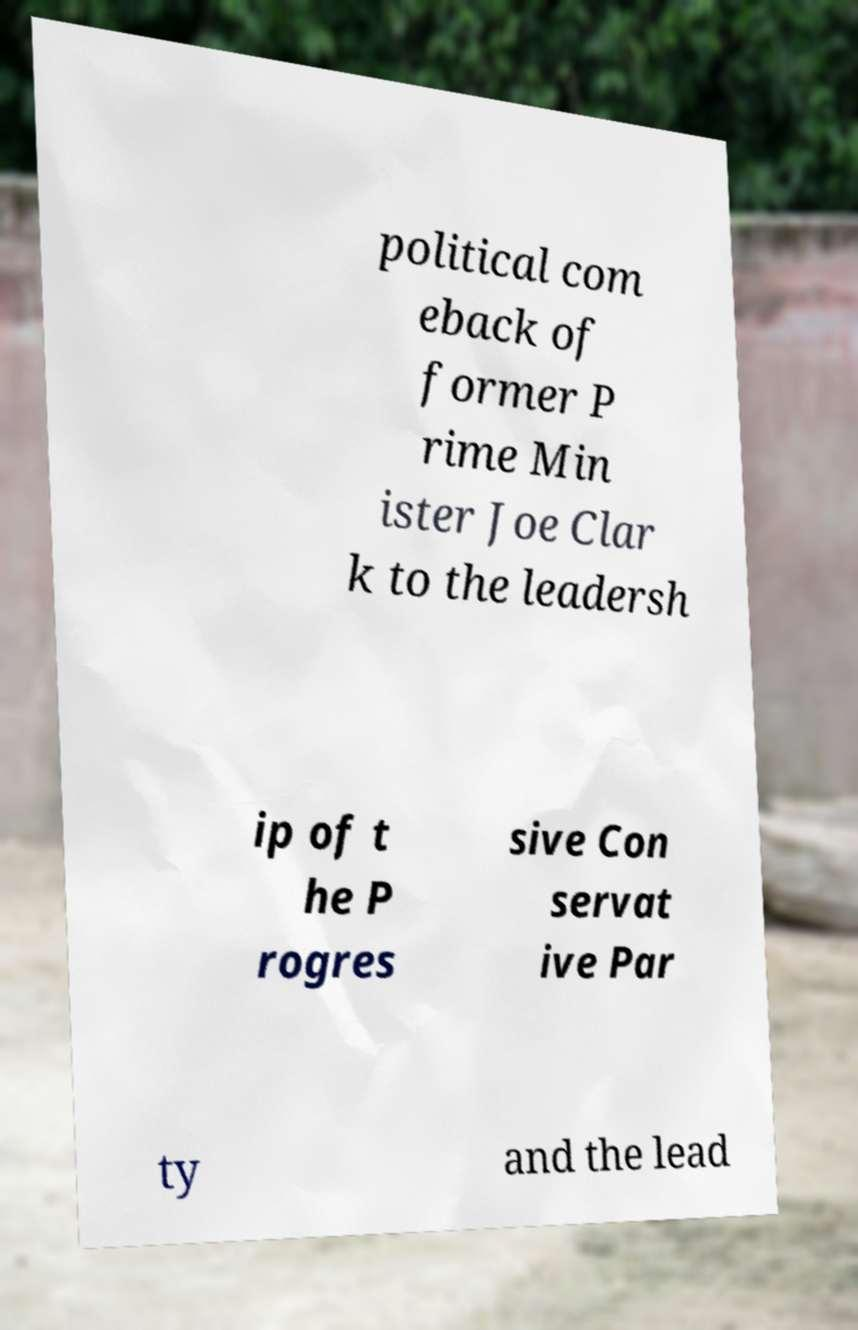For documentation purposes, I need the text within this image transcribed. Could you provide that? political com eback of former P rime Min ister Joe Clar k to the leadersh ip of t he P rogres sive Con servat ive Par ty and the lead 